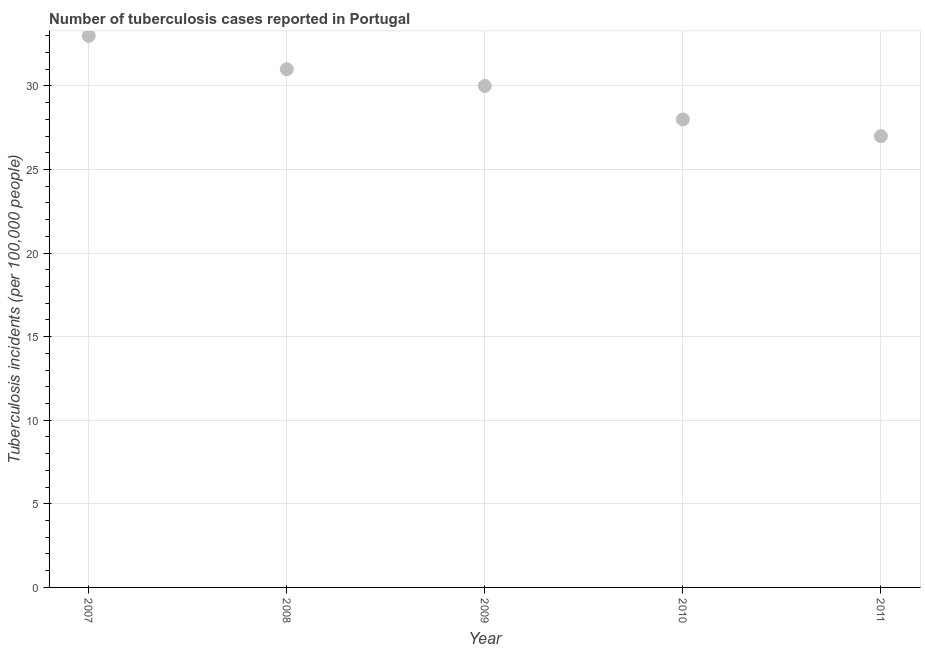What is the number of tuberculosis incidents in 2010?
Your answer should be very brief. 28. Across all years, what is the maximum number of tuberculosis incidents?
Provide a succinct answer. 33. Across all years, what is the minimum number of tuberculosis incidents?
Your response must be concise. 27. What is the sum of the number of tuberculosis incidents?
Your response must be concise. 149. What is the difference between the number of tuberculosis incidents in 2009 and 2011?
Make the answer very short. 3. What is the average number of tuberculosis incidents per year?
Keep it short and to the point. 29.8. What is the median number of tuberculosis incidents?
Ensure brevity in your answer.  30. In how many years, is the number of tuberculosis incidents greater than 29 ?
Make the answer very short. 3. What is the ratio of the number of tuberculosis incidents in 2009 to that in 2010?
Keep it short and to the point. 1.07. Is the number of tuberculosis incidents in 2008 less than that in 2010?
Keep it short and to the point. No. What is the difference between the highest and the second highest number of tuberculosis incidents?
Keep it short and to the point. 2. Is the sum of the number of tuberculosis incidents in 2007 and 2010 greater than the maximum number of tuberculosis incidents across all years?
Your response must be concise. Yes. What is the difference between the highest and the lowest number of tuberculosis incidents?
Provide a succinct answer. 6. In how many years, is the number of tuberculosis incidents greater than the average number of tuberculosis incidents taken over all years?
Your response must be concise. 3. Does the number of tuberculosis incidents monotonically increase over the years?
Your answer should be compact. No. What is the difference between two consecutive major ticks on the Y-axis?
Provide a succinct answer. 5. Are the values on the major ticks of Y-axis written in scientific E-notation?
Give a very brief answer. No. Does the graph contain grids?
Provide a short and direct response. Yes. What is the title of the graph?
Provide a short and direct response. Number of tuberculosis cases reported in Portugal. What is the label or title of the Y-axis?
Ensure brevity in your answer.  Tuberculosis incidents (per 100,0 people). What is the Tuberculosis incidents (per 100,000 people) in 2011?
Ensure brevity in your answer.  27. What is the difference between the Tuberculosis incidents (per 100,000 people) in 2007 and 2008?
Your answer should be very brief. 2. What is the difference between the Tuberculosis incidents (per 100,000 people) in 2007 and 2009?
Your answer should be compact. 3. What is the difference between the Tuberculosis incidents (per 100,000 people) in 2008 and 2009?
Ensure brevity in your answer.  1. What is the difference between the Tuberculosis incidents (per 100,000 people) in 2009 and 2011?
Your answer should be very brief. 3. What is the ratio of the Tuberculosis incidents (per 100,000 people) in 2007 to that in 2008?
Give a very brief answer. 1.06. What is the ratio of the Tuberculosis incidents (per 100,000 people) in 2007 to that in 2010?
Provide a short and direct response. 1.18. What is the ratio of the Tuberculosis incidents (per 100,000 people) in 2007 to that in 2011?
Make the answer very short. 1.22. What is the ratio of the Tuberculosis incidents (per 100,000 people) in 2008 to that in 2009?
Offer a very short reply. 1.03. What is the ratio of the Tuberculosis incidents (per 100,000 people) in 2008 to that in 2010?
Make the answer very short. 1.11. What is the ratio of the Tuberculosis incidents (per 100,000 people) in 2008 to that in 2011?
Your answer should be compact. 1.15. What is the ratio of the Tuberculosis incidents (per 100,000 people) in 2009 to that in 2010?
Give a very brief answer. 1.07. What is the ratio of the Tuberculosis incidents (per 100,000 people) in 2009 to that in 2011?
Provide a succinct answer. 1.11. What is the ratio of the Tuberculosis incidents (per 100,000 people) in 2010 to that in 2011?
Offer a terse response. 1.04. 